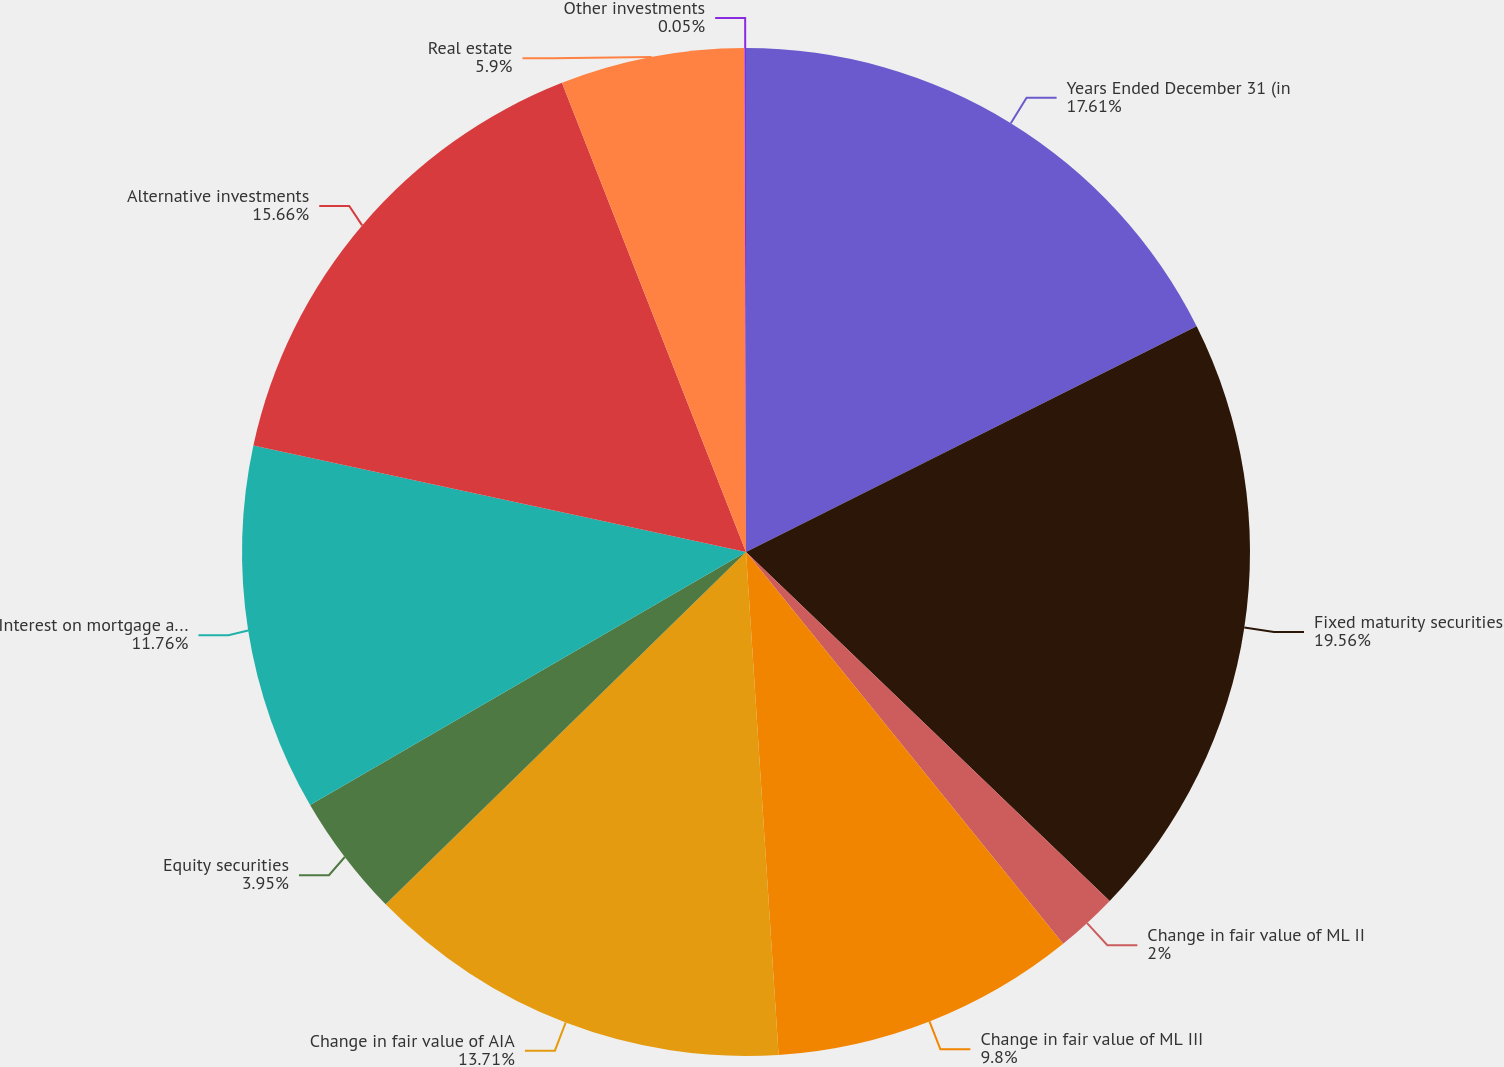Convert chart to OTSL. <chart><loc_0><loc_0><loc_500><loc_500><pie_chart><fcel>Years Ended December 31 (in<fcel>Fixed maturity securities<fcel>Change in fair value of ML II<fcel>Change in fair value of ML III<fcel>Change in fair value of AIA<fcel>Equity securities<fcel>Interest on mortgage and other<fcel>Alternative investments<fcel>Real estate<fcel>Other investments<nl><fcel>17.61%<fcel>19.56%<fcel>2.0%<fcel>9.8%<fcel>13.71%<fcel>3.95%<fcel>11.76%<fcel>15.66%<fcel>5.9%<fcel>0.05%<nl></chart> 